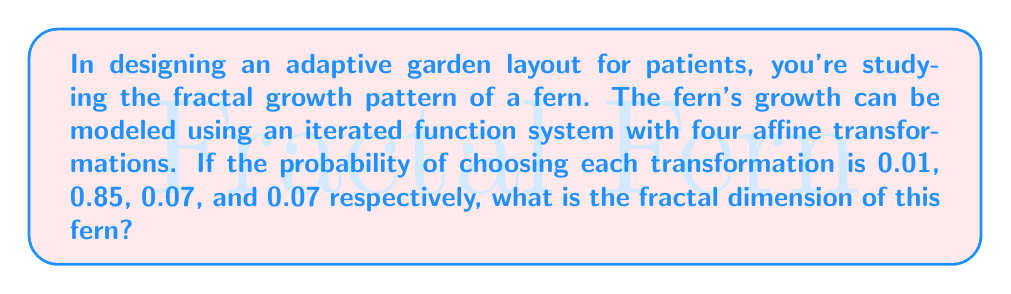What is the answer to this math problem? To find the fractal dimension of the fern, we'll use the concept of self-similarity dimension. The steps are as follows:

1) In an iterated function system (IFS), the fractal dimension $D$ is given by the equation:

   $$\sum_{i=1}^n p_i^D = 1$$

   where $p_i$ are the probabilities of choosing each transformation.

2) For our fern, we have:

   $$0.01^D + 0.85^D + 0.07^D + 0.07^D = 1$$

3) This equation can't be solved algebraically, so we need to use numerical methods. We can use the bisection method or Newton's method to solve it.

4) Using a numerical solver, we find that $D \approx 2.0586$.

5) This value makes sense for a fern-like structure, as it's between 2 (a plane) and 3 (a volume), indicating a complex, space-filling curve.

6) For garden layout optimization, this dimension suggests that the fern will efficiently fill space, which could be useful for maximizing plant density while maintaining aesthetic appeal and accessibility for patients using adaptive gardening tools.
Answer: $D \approx 2.0586$ 